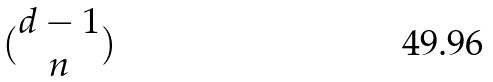<formula> <loc_0><loc_0><loc_500><loc_500>( \begin{matrix} d - 1 \\ n \end{matrix} )</formula> 